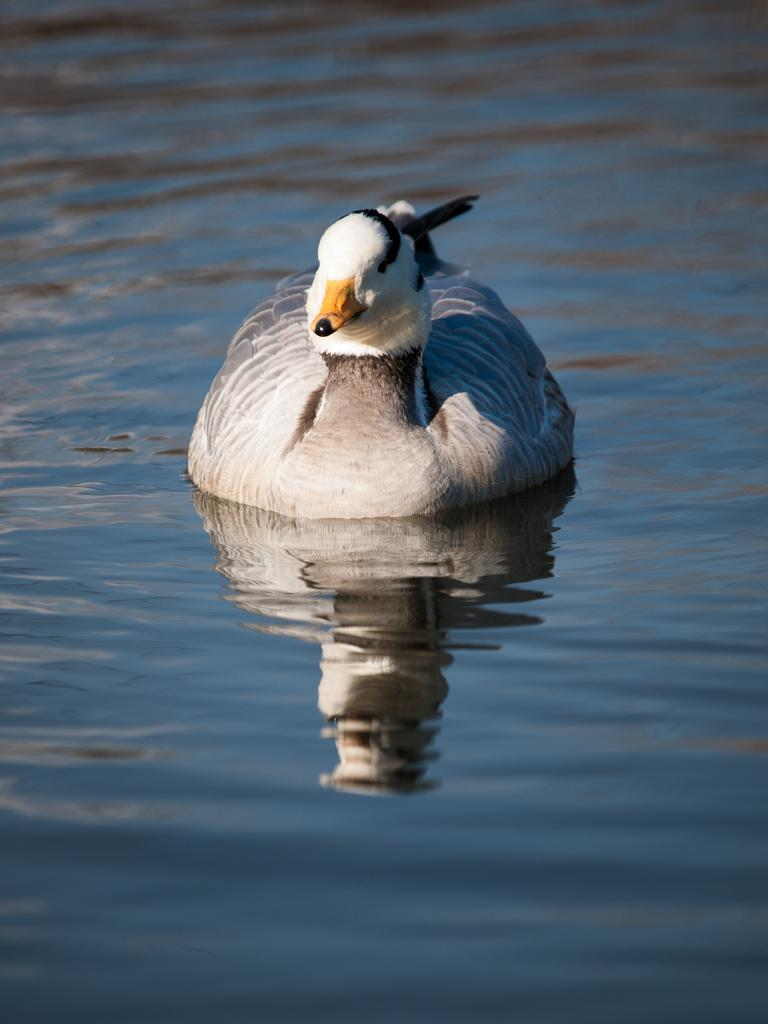What animal is present in the image? There is a duck in the image. What is the duck doing in the image? The duck is swimming on the water. What color is the duck's beak? The duck has a yellow beak. How many clams can be seen attached to the duck's foot in the image? There are no clams or feet visible in the image, as it features a duck swimming on the water with a yellow beak. 